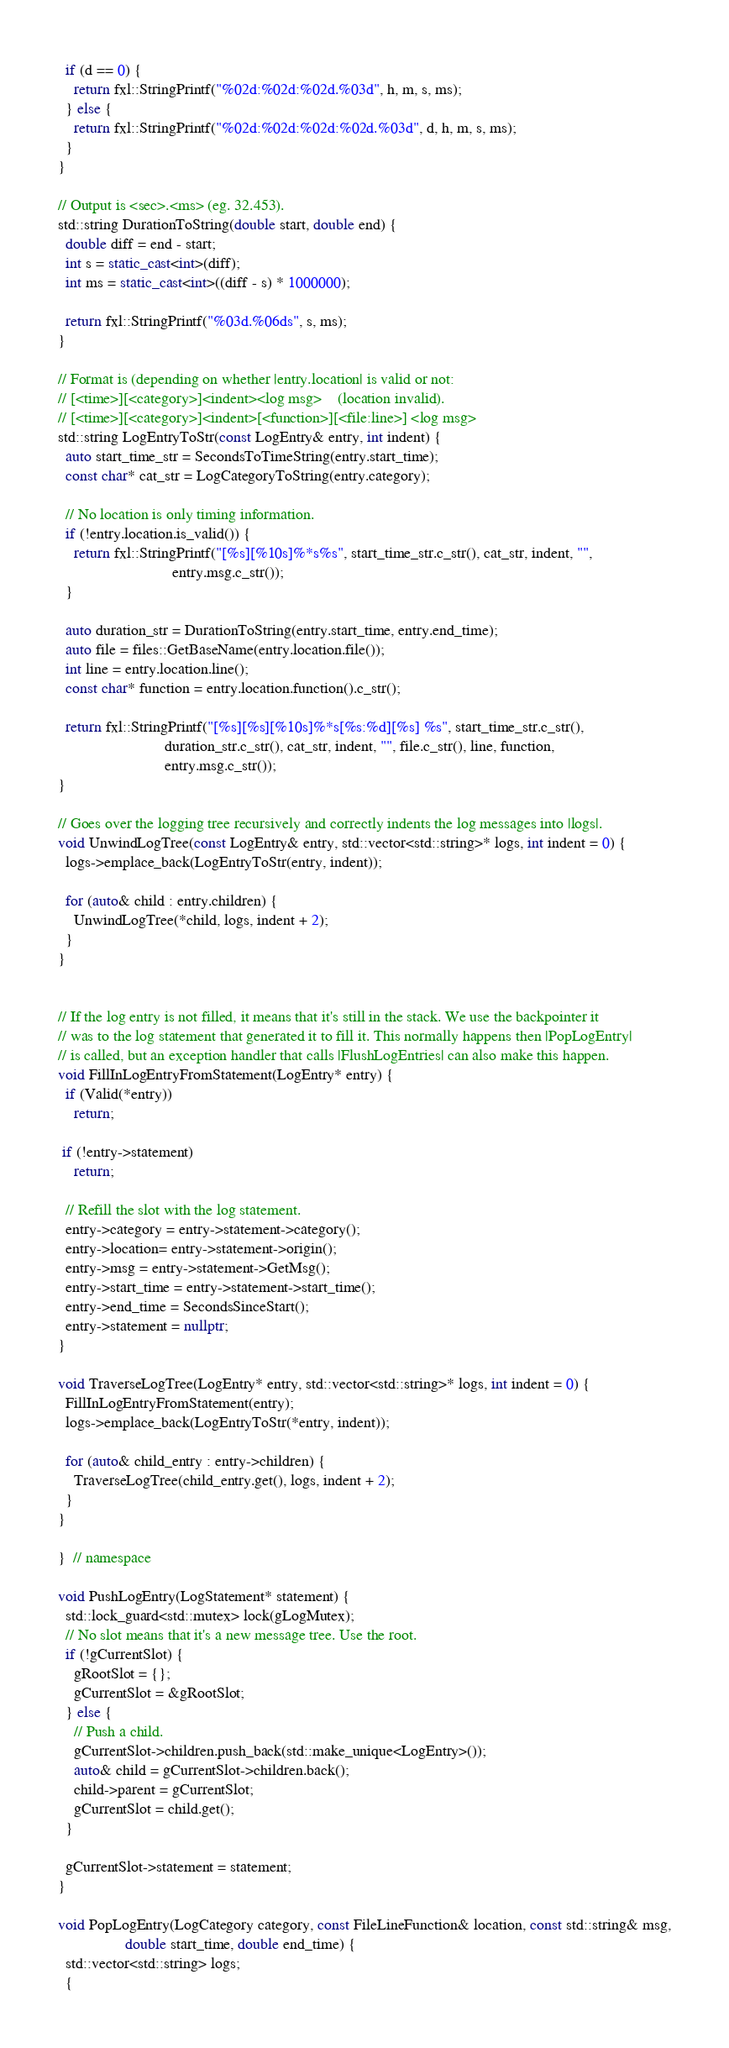<code> <loc_0><loc_0><loc_500><loc_500><_C++_>  if (d == 0) {
    return fxl::StringPrintf("%02d:%02d:%02d.%03d", h, m, s, ms);
  } else {
    return fxl::StringPrintf("%02d:%02d:%02d:%02d.%03d", d, h, m, s, ms);
  }
}

// Output is <sec>.<ms> (eg. 32.453).
std::string DurationToString(double start, double end) {
  double diff = end - start;
  int s = static_cast<int>(diff);
  int ms = static_cast<int>((diff - s) * 1000000);

  return fxl::StringPrintf("%03d.%06ds", s, ms);
}

// Format is (depending on whether |entry.location| is valid or not:
// [<time>][<category>]<indent><log msg>    (location invalid).
// [<time>][<category>]<indent>[<function>][<file:line>] <log msg>
std::string LogEntryToStr(const LogEntry& entry, int indent) {
  auto start_time_str = SecondsToTimeString(entry.start_time);
  const char* cat_str = LogCategoryToString(entry.category);

  // No location is only timing information.
  if (!entry.location.is_valid()) {
    return fxl::StringPrintf("[%s][%10s]%*s%s", start_time_str.c_str(), cat_str, indent, "",
                             entry.msg.c_str());
  }

  auto duration_str = DurationToString(entry.start_time, entry.end_time);
  auto file = files::GetBaseName(entry.location.file());
  int line = entry.location.line();
  const char* function = entry.location.function().c_str();

  return fxl::StringPrintf("[%s][%s][%10s]%*s[%s:%d][%s] %s", start_time_str.c_str(),
                           duration_str.c_str(), cat_str, indent, "", file.c_str(), line, function,
                           entry.msg.c_str());
}

// Goes over the logging tree recursively and correctly indents the log messages into |logs|.
void UnwindLogTree(const LogEntry& entry, std::vector<std::string>* logs, int indent = 0) {
  logs->emplace_back(LogEntryToStr(entry, indent));

  for (auto& child : entry.children) {
    UnwindLogTree(*child, logs, indent + 2);
  }
}


// If the log entry is not filled, it means that it's still in the stack. We use the backpointer it
// was to the log statement that generated it to fill it. This normally happens then |PopLogEntry|
// is called, but an exception handler that calls |FlushLogEntries| can also make this happen.
void FillInLogEntryFromStatement(LogEntry* entry) {
  if (Valid(*entry))
    return;

 if (!entry->statement)
    return;

  // Refill the slot with the log statement.
  entry->category = entry->statement->category();
  entry->location= entry->statement->origin();
  entry->msg = entry->statement->GetMsg();
  entry->start_time = entry->statement->start_time();
  entry->end_time = SecondsSinceStart();
  entry->statement = nullptr;
}

void TraverseLogTree(LogEntry* entry, std::vector<std::string>* logs, int indent = 0) {
  FillInLogEntryFromStatement(entry);
  logs->emplace_back(LogEntryToStr(*entry, indent));

  for (auto& child_entry : entry->children) {
    TraverseLogTree(child_entry.get(), logs, indent + 2);
  }
}

}  // namespace

void PushLogEntry(LogStatement* statement) {
  std::lock_guard<std::mutex> lock(gLogMutex);
  // No slot means that it's a new message tree. Use the root.
  if (!gCurrentSlot) {
    gRootSlot = {};
    gCurrentSlot = &gRootSlot;
  } else {
    // Push a child.
    gCurrentSlot->children.push_back(std::make_unique<LogEntry>());
    auto& child = gCurrentSlot->children.back();
    child->parent = gCurrentSlot;
    gCurrentSlot = child.get();
  }

  gCurrentSlot->statement = statement;
}

void PopLogEntry(LogCategory category, const FileLineFunction& location, const std::string& msg,
                 double start_time, double end_time) {
  std::vector<std::string> logs;
  {</code> 